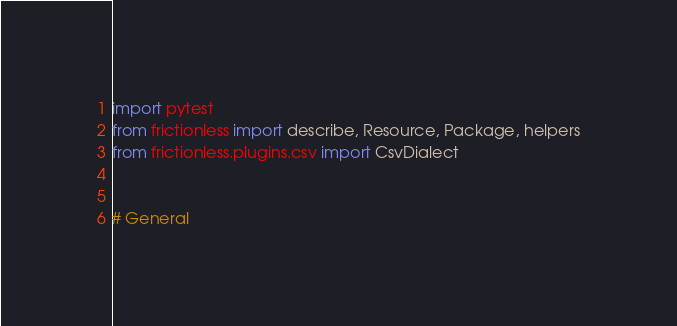Convert code to text. <code><loc_0><loc_0><loc_500><loc_500><_Python_>import pytest
from frictionless import describe, Resource, Package, helpers
from frictionless.plugins.csv import CsvDialect


# General

</code> 